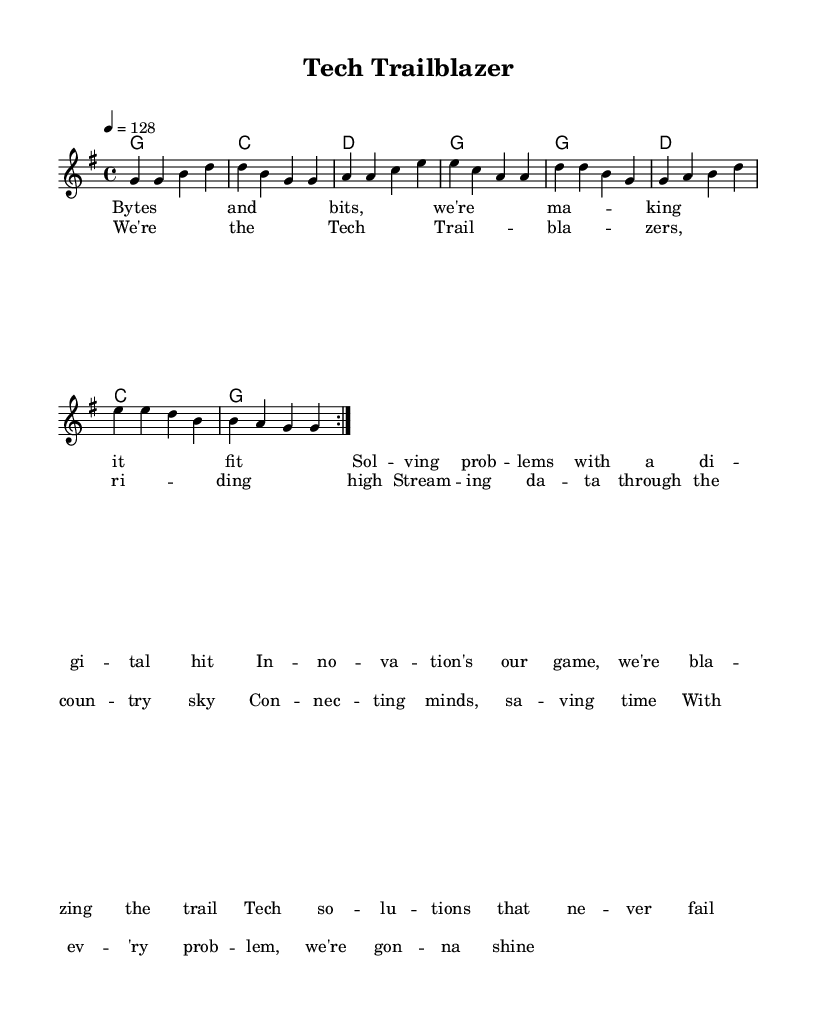What is the key signature of this music? The key signature indicates G major, which has one sharp (F#) as denoted by the presence of the note G as the tonic and notations in the music.
Answer: G major What is the time signature of this music? The time signature is indicated at the beginning of the score as 4/4, which means there are four beats in a measure and the quarter note gets one beat.
Answer: 4/4 What is the tempo marking for this piece? The tempo marking is indicated by the number 128 under the tempo instruction, which signifies beats per minute and gives the performance speed of the piece.
Answer: 128 How many measures are in the repeated section of the melody? The repeated section of the melody includes 8 measures, as indicated by the repeat markings and the structure of the melody section.
Answer: 8 What is the title of this song? The title is presented at the top of the score in the header section, labeled clearly as "Tech Trailblazer" which reflects the theme of innovation in the lyrics.
Answer: Tech Trailblazer What are the first two lines of the verse lyrics? The first two lines of the verse lyrics are directly provided in the lyric mode section, and they can be counted to find the answer reflecting the content related to problem-solving.
Answer: Bytes and bits, we're making it fit What is the main theme of the song related to Country Rock? The main theme revolves around problem-solving and innovation as depicted in the lyrics and title, consistent with the upbeat spirit of Country Rock which often celebrates overcoming challenges.
Answer: Problem-solving and innovation 